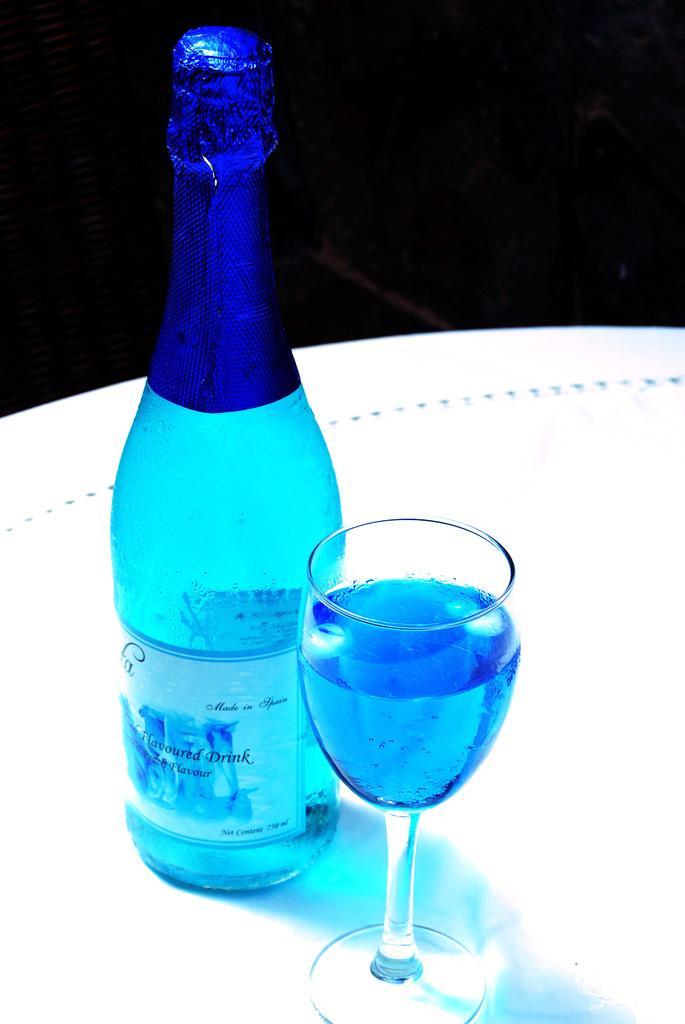Please provide a concise description of this image. There is a wine bottle and a glass of wine on the table. 